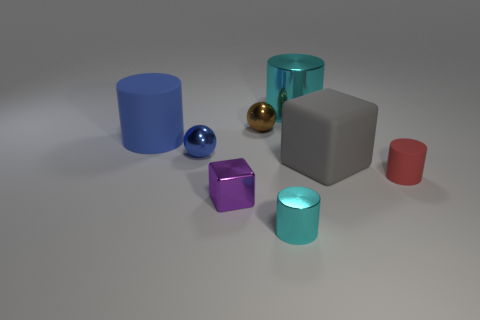Subtract all gray cylinders. Subtract all red blocks. How many cylinders are left? 4 Add 1 tiny purple things. How many objects exist? 9 Subtract all spheres. How many objects are left? 6 Subtract all small gray shiny blocks. Subtract all red cylinders. How many objects are left? 7 Add 3 red matte cylinders. How many red matte cylinders are left? 4 Add 2 large blue things. How many large blue things exist? 3 Subtract 1 cyan cylinders. How many objects are left? 7 